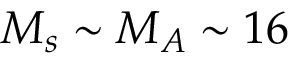<formula> <loc_0><loc_0><loc_500><loc_500>M _ { s } \sim M _ { A } \sim 1 6</formula> 